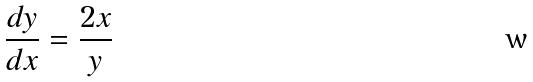<formula> <loc_0><loc_0><loc_500><loc_500>\frac { d y } { d x } = \frac { 2 x } { y }</formula> 